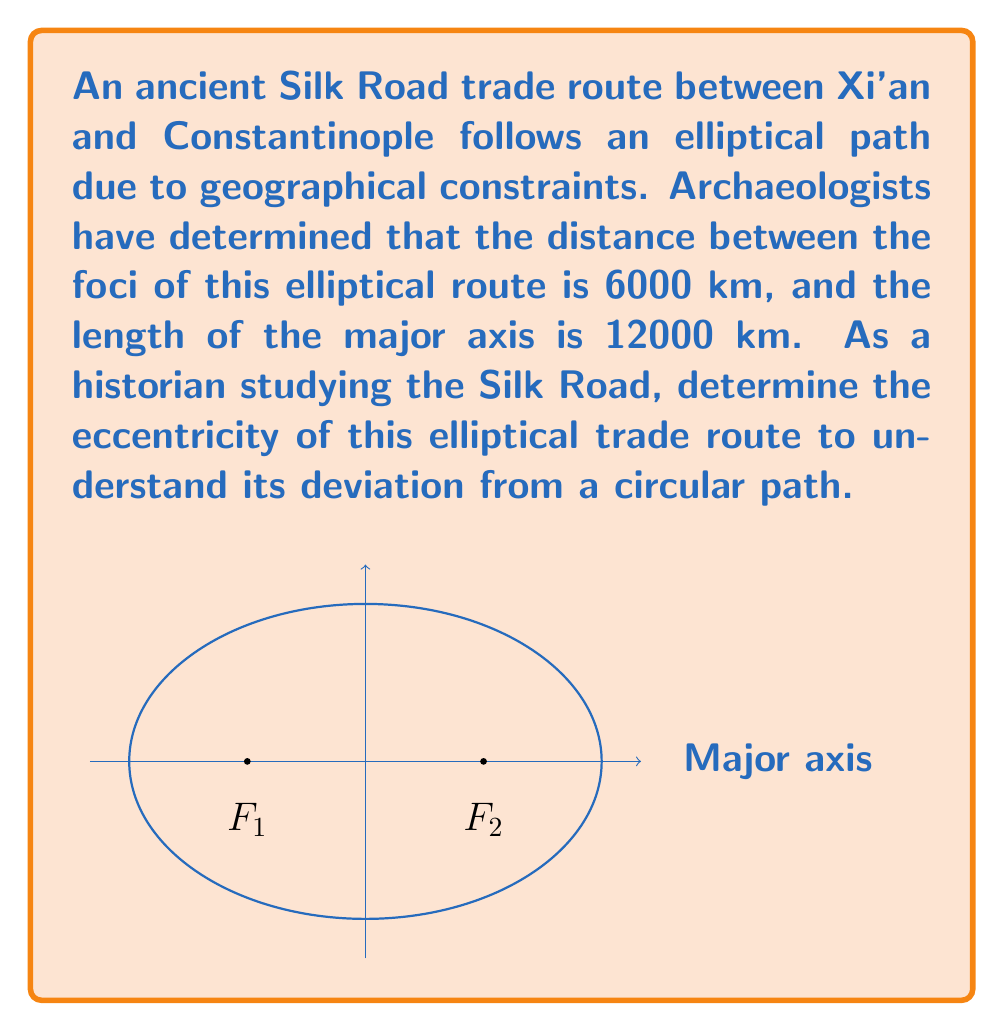What is the answer to this math problem? Let's approach this step-by-step:

1) In an ellipse, eccentricity ($e$) is defined as the ratio of the distance between the foci to the length of the major axis. It can be calculated using the formula:

   $$e = \frac{c}{a}$$

   where $c$ is half the distance between the foci, and $a$ is half the length of the major axis.

2) From the given information:
   - Distance between foci = 6000 km
   - Length of major axis = 12000 km

3) Calculate $c$:
   $$c = \frac{6000}{2} = 3000 \text{ km}$$

4) Calculate $a$:
   $$a = \frac{12000}{2} = 6000 \text{ km}$$

5) Now, we can substitute these values into the eccentricity formula:

   $$e = \frac{c}{a} = \frac{3000}{6000} = \frac{1}{2} = 0.5$$

6) Therefore, the eccentricity of the elliptical trade route is 0.5.

This eccentricity value of 0.5 indicates that the elliptical path deviates moderately from a circular shape. In the context of the Silk Road, this could reflect how geographical features like mountain ranges or deserts influenced the trade route's shape.
Answer: $0.5$ 